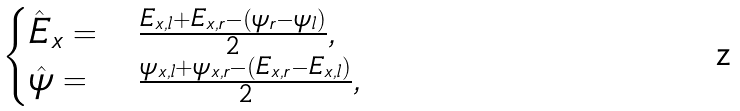<formula> <loc_0><loc_0><loc_500><loc_500>\begin{cases} \hat { E } _ { x } = & \frac { E _ { x , l } + E _ { x , r } - ( \psi _ { r } - \psi _ { l } ) } { 2 } , \\ \hat { \psi } = & \frac { \psi _ { x , l } + \psi _ { x , r } - ( E _ { x , r } - E _ { x , l } ) } { 2 } , \\ \end{cases}</formula> 